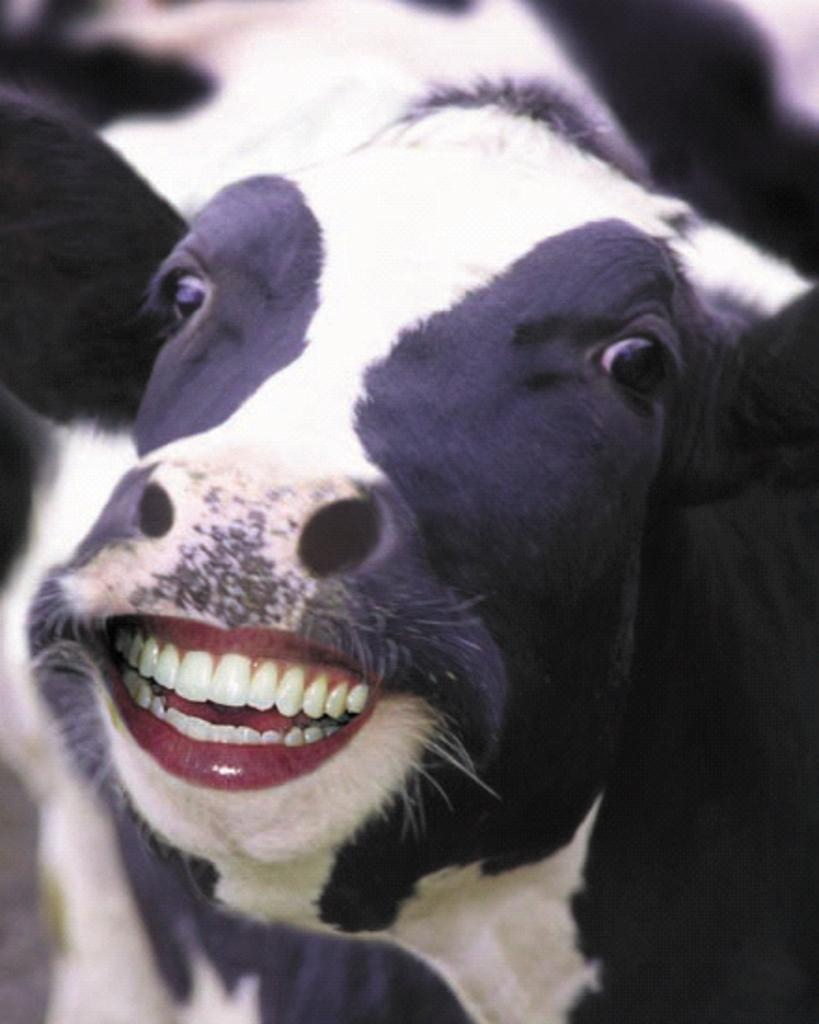What type of animal is present in the image? There is a cow in the image. Can you see a hole in the cow's ear in the image? There is no mention of a hole in the cow's ear in the provided fact, and therefore it cannot be determined from the image. 